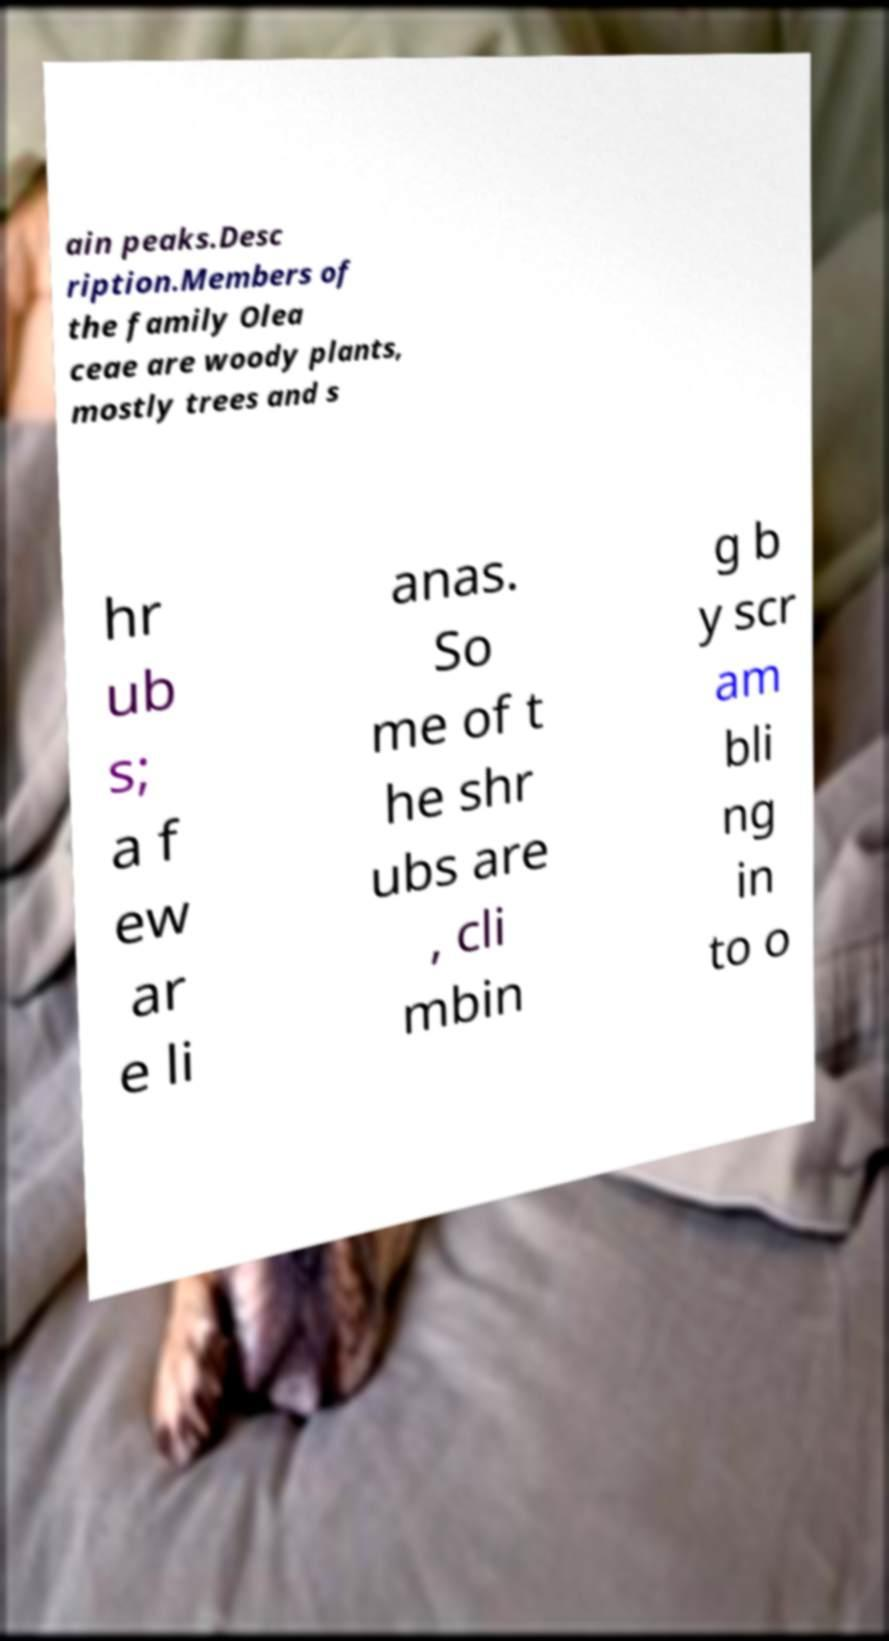For documentation purposes, I need the text within this image transcribed. Could you provide that? ain peaks.Desc ription.Members of the family Olea ceae are woody plants, mostly trees and s hr ub s; a f ew ar e li anas. So me of t he shr ubs are , cli mbin g b y scr am bli ng in to o 